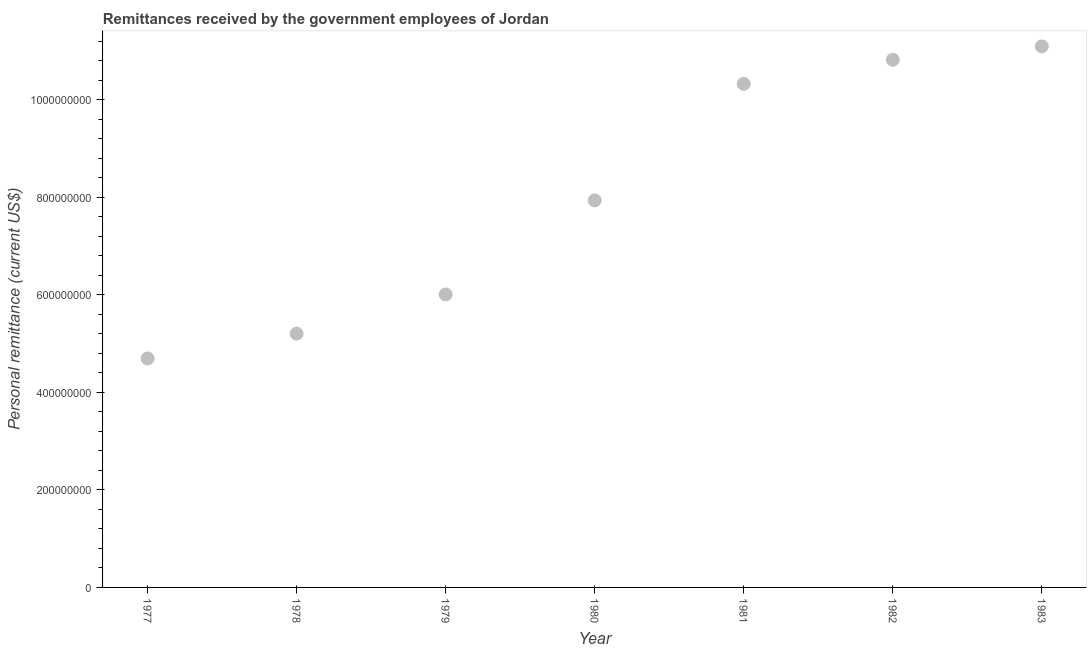What is the personal remittances in 1982?
Your response must be concise. 1.08e+09. Across all years, what is the maximum personal remittances?
Offer a very short reply. 1.11e+09. Across all years, what is the minimum personal remittances?
Your response must be concise. 4.70e+08. In which year was the personal remittances minimum?
Your answer should be compact. 1977. What is the sum of the personal remittances?
Provide a succinct answer. 5.61e+09. What is the difference between the personal remittances in 1981 and 1982?
Your answer should be compact. -4.93e+07. What is the average personal remittances per year?
Your response must be concise. 8.01e+08. What is the median personal remittances?
Your answer should be compact. 7.94e+08. Do a majority of the years between 1982 and 1978 (inclusive) have personal remittances greater than 200000000 US$?
Your answer should be compact. Yes. What is the ratio of the personal remittances in 1980 to that in 1981?
Your answer should be very brief. 0.77. Is the personal remittances in 1977 less than that in 1983?
Ensure brevity in your answer.  Yes. Is the difference between the personal remittances in 1977 and 1979 greater than the difference between any two years?
Provide a succinct answer. No. What is the difference between the highest and the second highest personal remittances?
Offer a very short reply. 2.73e+07. Is the sum of the personal remittances in 1979 and 1982 greater than the maximum personal remittances across all years?
Offer a terse response. Yes. What is the difference between the highest and the lowest personal remittances?
Give a very brief answer. 6.40e+08. How many dotlines are there?
Make the answer very short. 1. What is the difference between two consecutive major ticks on the Y-axis?
Ensure brevity in your answer.  2.00e+08. Are the values on the major ticks of Y-axis written in scientific E-notation?
Ensure brevity in your answer.  No. Does the graph contain any zero values?
Provide a succinct answer. No. What is the title of the graph?
Your response must be concise. Remittances received by the government employees of Jordan. What is the label or title of the X-axis?
Offer a very short reply. Year. What is the label or title of the Y-axis?
Provide a succinct answer. Personal remittance (current US$). What is the Personal remittance (current US$) in 1977?
Ensure brevity in your answer.  4.70e+08. What is the Personal remittance (current US$) in 1978?
Make the answer very short. 5.21e+08. What is the Personal remittance (current US$) in 1979?
Provide a succinct answer. 6.01e+08. What is the Personal remittance (current US$) in 1980?
Provide a short and direct response. 7.94e+08. What is the Personal remittance (current US$) in 1981?
Offer a terse response. 1.03e+09. What is the Personal remittance (current US$) in 1982?
Make the answer very short. 1.08e+09. What is the Personal remittance (current US$) in 1983?
Ensure brevity in your answer.  1.11e+09. What is the difference between the Personal remittance (current US$) in 1977 and 1978?
Offer a terse response. -5.09e+07. What is the difference between the Personal remittance (current US$) in 1977 and 1979?
Make the answer very short. -1.31e+08. What is the difference between the Personal remittance (current US$) in 1977 and 1980?
Provide a short and direct response. -3.24e+08. What is the difference between the Personal remittance (current US$) in 1977 and 1981?
Give a very brief answer. -5.63e+08. What is the difference between the Personal remittance (current US$) in 1977 and 1982?
Give a very brief answer. -6.13e+08. What is the difference between the Personal remittance (current US$) in 1977 and 1983?
Your answer should be compact. -6.40e+08. What is the difference between the Personal remittance (current US$) in 1978 and 1979?
Provide a short and direct response. -8.04e+07. What is the difference between the Personal remittance (current US$) in 1978 and 1980?
Your answer should be very brief. -2.73e+08. What is the difference between the Personal remittance (current US$) in 1978 and 1981?
Keep it short and to the point. -5.12e+08. What is the difference between the Personal remittance (current US$) in 1978 and 1982?
Your answer should be very brief. -5.62e+08. What is the difference between the Personal remittance (current US$) in 1978 and 1983?
Your answer should be very brief. -5.89e+08. What is the difference between the Personal remittance (current US$) in 1979 and 1980?
Offer a terse response. -1.93e+08. What is the difference between the Personal remittance (current US$) in 1979 and 1981?
Your answer should be very brief. -4.32e+08. What is the difference between the Personal remittance (current US$) in 1979 and 1982?
Make the answer very short. -4.81e+08. What is the difference between the Personal remittance (current US$) in 1979 and 1983?
Offer a very short reply. -5.09e+08. What is the difference between the Personal remittance (current US$) in 1980 and 1981?
Your response must be concise. -2.39e+08. What is the difference between the Personal remittance (current US$) in 1980 and 1982?
Keep it short and to the point. -2.88e+08. What is the difference between the Personal remittance (current US$) in 1980 and 1983?
Keep it short and to the point. -3.16e+08. What is the difference between the Personal remittance (current US$) in 1981 and 1982?
Ensure brevity in your answer.  -4.93e+07. What is the difference between the Personal remittance (current US$) in 1981 and 1983?
Provide a succinct answer. -7.67e+07. What is the difference between the Personal remittance (current US$) in 1982 and 1983?
Give a very brief answer. -2.73e+07. What is the ratio of the Personal remittance (current US$) in 1977 to that in 1978?
Make the answer very short. 0.9. What is the ratio of the Personal remittance (current US$) in 1977 to that in 1979?
Your response must be concise. 0.78. What is the ratio of the Personal remittance (current US$) in 1977 to that in 1980?
Ensure brevity in your answer.  0.59. What is the ratio of the Personal remittance (current US$) in 1977 to that in 1981?
Your answer should be compact. 0.46. What is the ratio of the Personal remittance (current US$) in 1977 to that in 1982?
Give a very brief answer. 0.43. What is the ratio of the Personal remittance (current US$) in 1977 to that in 1983?
Give a very brief answer. 0.42. What is the ratio of the Personal remittance (current US$) in 1978 to that in 1979?
Provide a succinct answer. 0.87. What is the ratio of the Personal remittance (current US$) in 1978 to that in 1980?
Make the answer very short. 0.66. What is the ratio of the Personal remittance (current US$) in 1978 to that in 1981?
Your answer should be compact. 0.5. What is the ratio of the Personal remittance (current US$) in 1978 to that in 1982?
Provide a succinct answer. 0.48. What is the ratio of the Personal remittance (current US$) in 1978 to that in 1983?
Offer a very short reply. 0.47. What is the ratio of the Personal remittance (current US$) in 1979 to that in 1980?
Offer a very short reply. 0.76. What is the ratio of the Personal remittance (current US$) in 1979 to that in 1981?
Keep it short and to the point. 0.58. What is the ratio of the Personal remittance (current US$) in 1979 to that in 1982?
Your answer should be very brief. 0.56. What is the ratio of the Personal remittance (current US$) in 1979 to that in 1983?
Provide a succinct answer. 0.54. What is the ratio of the Personal remittance (current US$) in 1980 to that in 1981?
Provide a short and direct response. 0.77. What is the ratio of the Personal remittance (current US$) in 1980 to that in 1982?
Your answer should be compact. 0.73. What is the ratio of the Personal remittance (current US$) in 1980 to that in 1983?
Provide a short and direct response. 0.71. What is the ratio of the Personal remittance (current US$) in 1981 to that in 1982?
Your answer should be very brief. 0.95. What is the ratio of the Personal remittance (current US$) in 1981 to that in 1983?
Offer a terse response. 0.93. What is the ratio of the Personal remittance (current US$) in 1982 to that in 1983?
Your answer should be compact. 0.97. 